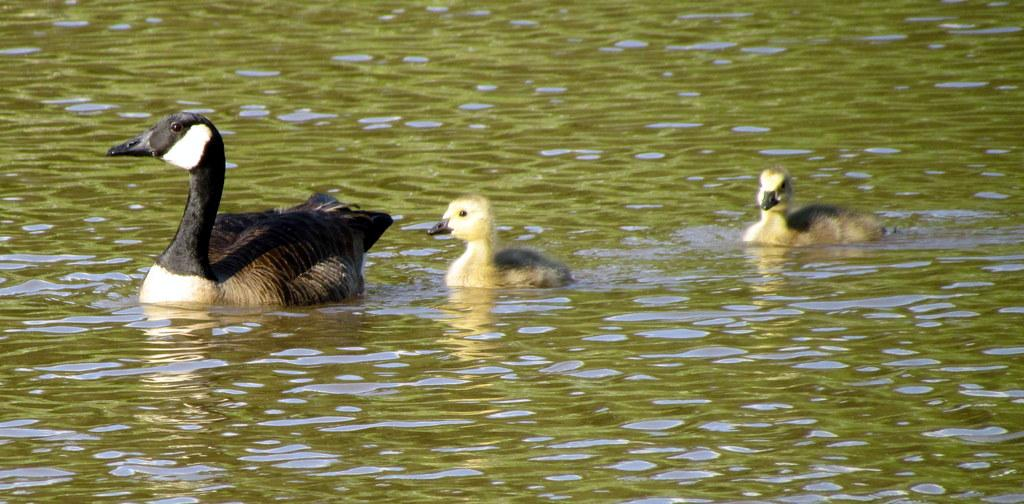What is the main subject of the image? The main subject of the image is a duck swimming in the water. Can you describe the duck's appearance? The duck is black in color. Are there any other ducks in the image? Yes, there are two ducklings swimming in the water. What type of beef can be seen hanging from the roof in the image? There is no beef or roof present in the image; it features a duck and ducklings swimming in the water. 